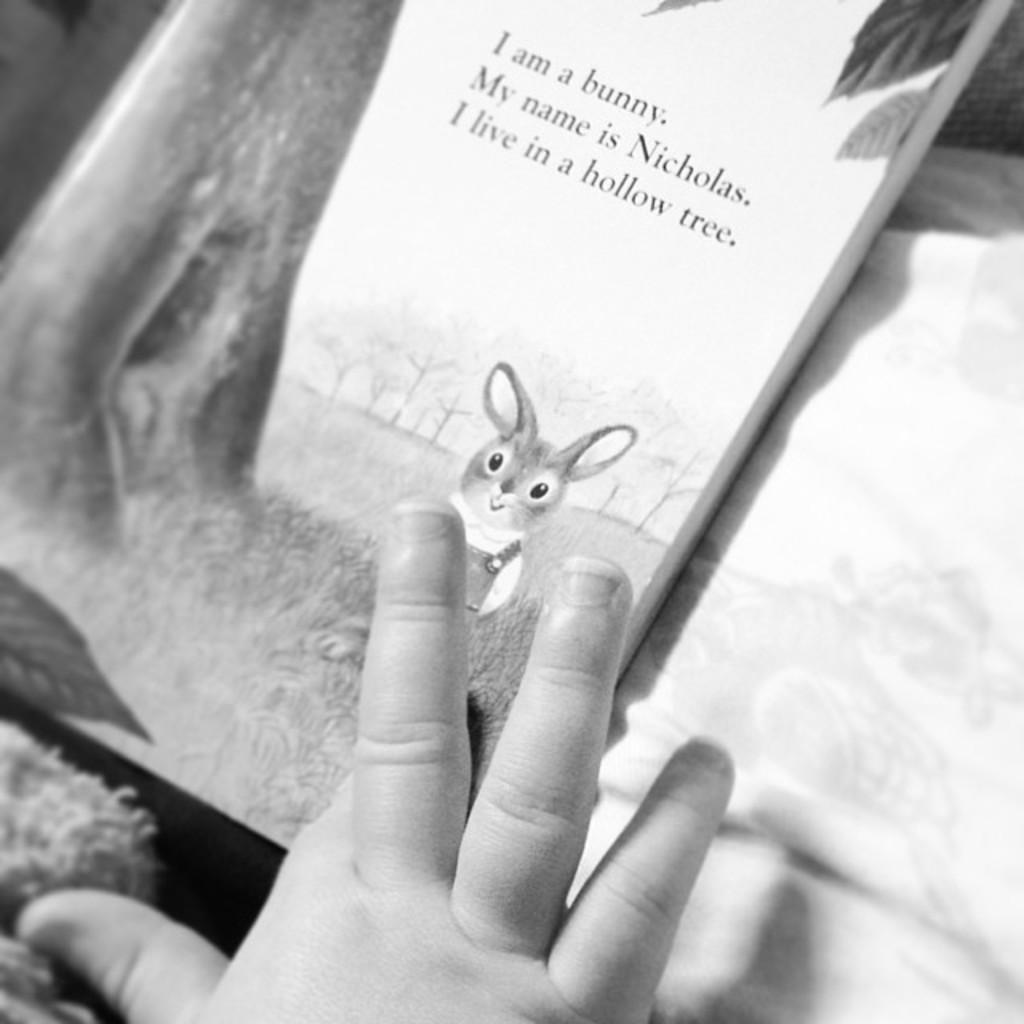In one or two sentences, can you explain what this image depicts? In this picture we can see the close view of the the book and small baby hand. 